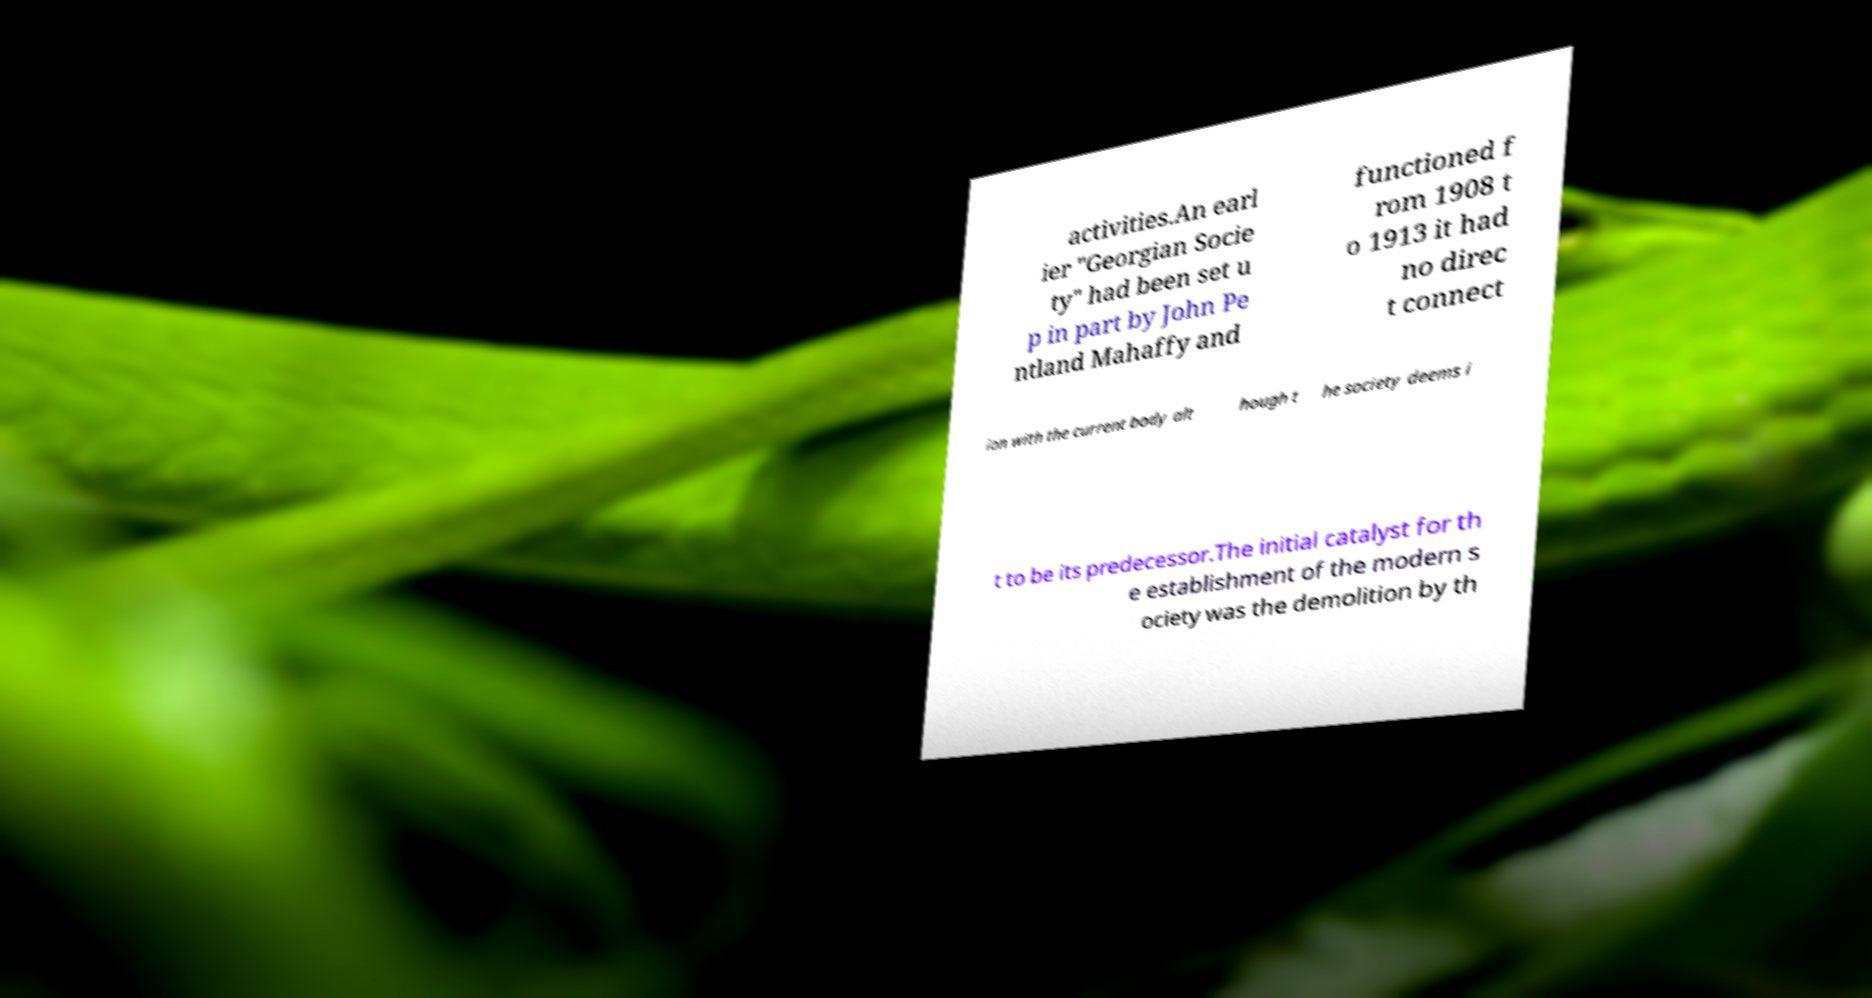There's text embedded in this image that I need extracted. Can you transcribe it verbatim? activities.An earl ier "Georgian Socie ty" had been set u p in part by John Pe ntland Mahaffy and functioned f rom 1908 t o 1913 it had no direc t connect ion with the current body alt hough t he society deems i t to be its predecessor.The initial catalyst for th e establishment of the modern s ociety was the demolition by th 